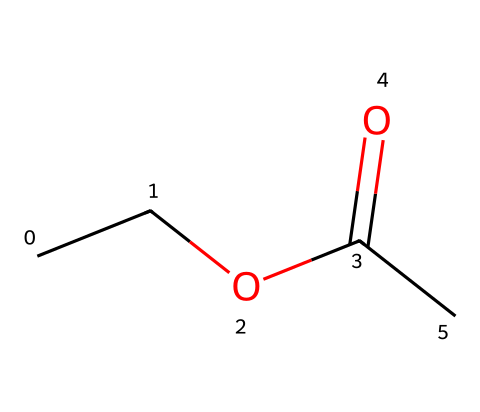How many carbon atoms are in ethyl acetate? In the SMILES representation "CCOC(=O)C," we can count the carbon (C) atoms indicated. There are four carbon atoms in total: two in the ethyl group (CC), one in the carbonyl (C=O) part, and one at the end.
Answer: 4 What functional group is present in ethyl acetate? The structure contains the carbonyl group (C=O) bonded to an alkoxy group (OCC), which is characteristic of esters. Esters specifically contain a carbonyl group bonded to an oxygen atom that is also connected to an alkyl or aliphatic moiety.
Answer: ester What is the total number of hydrogen atoms in ethyl acetate? From the ethyl group (C2H5), we have five hydrogens; the carbonyl group contributes no hydrogens, and the terminal carbon adds three more hydrogens. Thus, adding these up gives a total of 8 hydrogen atoms.
Answer: 8 Which atom connects the ethyl group and the carbonyl group? In the SMILES "CCOC(=O)C," the oxygen atom (O) connects the ethyl group (CC) to the carbonyl group (C=O). This connection is integral to the structure of an ester.
Answer: oxygen Why is ethyl acetate considered a polar molecule? Ethyl acetate has a polar carbonyl group (C=O) due to the electronegativity difference between carbon and oxygen, which creates a dipole moment. This polarity is also supported by the ether-like structure of the ester linkage, contributing to its overall polar character.
Answer: polar What is the primary use of ethyl acetate in electronics manufacturing? Ethyl acetate is primarily used as a solvent in the electronics manufacturing process due to its ability to dissolve oils, resins, and other materials effectively while being relatively volatile.
Answer: solvent 